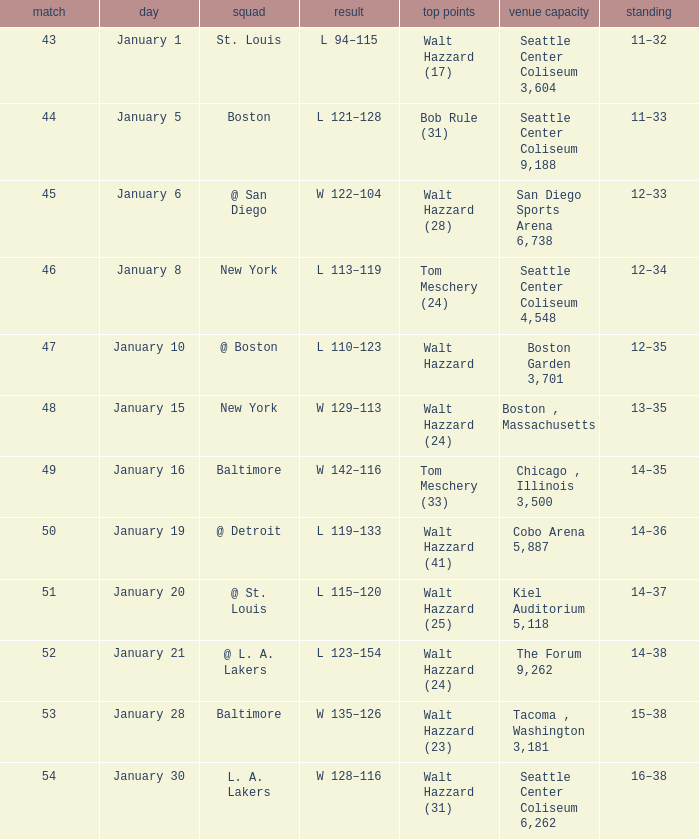What is the record for the St. Louis team? 11–32. Parse the table in full. {'header': ['match', 'day', 'squad', 'result', 'top points', 'venue capacity', 'standing'], 'rows': [['43', 'January 1', 'St. Louis', 'L 94–115', 'Walt Hazzard (17)', 'Seattle Center Coliseum 3,604', '11–32'], ['44', 'January 5', 'Boston', 'L 121–128', 'Bob Rule (31)', 'Seattle Center Coliseum 9,188', '11–33'], ['45', 'January 6', '@ San Diego', 'W 122–104', 'Walt Hazzard (28)', 'San Diego Sports Arena 6,738', '12–33'], ['46', 'January 8', 'New York', 'L 113–119', 'Tom Meschery (24)', 'Seattle Center Coliseum 4,548', '12–34'], ['47', 'January 10', '@ Boston', 'L 110–123', 'Walt Hazzard', 'Boston Garden 3,701', '12–35'], ['48', 'January 15', 'New York', 'W 129–113', 'Walt Hazzard (24)', 'Boston , Massachusetts', '13–35'], ['49', 'January 16', 'Baltimore', 'W 142–116', 'Tom Meschery (33)', 'Chicago , Illinois 3,500', '14–35'], ['50', 'January 19', '@ Detroit', 'L 119–133', 'Walt Hazzard (41)', 'Cobo Arena 5,887', '14–36'], ['51', 'January 20', '@ St. Louis', 'L 115–120', 'Walt Hazzard (25)', 'Kiel Auditorium 5,118', '14–37'], ['52', 'January 21', '@ L. A. Lakers', 'L 123–154', 'Walt Hazzard (24)', 'The Forum 9,262', '14–38'], ['53', 'January 28', 'Baltimore', 'W 135–126', 'Walt Hazzard (23)', 'Tacoma , Washington 3,181', '15–38'], ['54', 'January 30', 'L. A. Lakers', 'W 128–116', 'Walt Hazzard (31)', 'Seattle Center Coliseum 6,262', '16–38']]} 